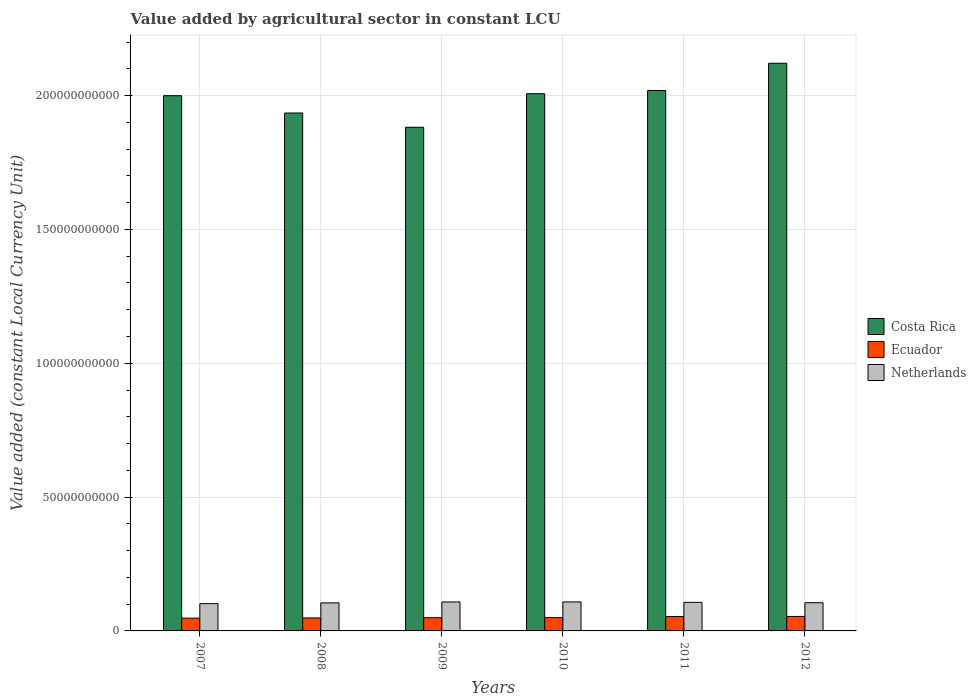How many groups of bars are there?
Ensure brevity in your answer.  6. How many bars are there on the 5th tick from the right?
Offer a terse response. 3. What is the label of the 5th group of bars from the left?
Provide a succinct answer. 2011. What is the value added by agricultural sector in Netherlands in 2007?
Offer a very short reply. 1.02e+1. Across all years, what is the maximum value added by agricultural sector in Ecuador?
Provide a succinct answer. 5.41e+09. Across all years, what is the minimum value added by agricultural sector in Ecuador?
Your answer should be compact. 4.77e+09. In which year was the value added by agricultural sector in Costa Rica maximum?
Ensure brevity in your answer.  2012. What is the total value added by agricultural sector in Costa Rica in the graph?
Your answer should be compact. 1.20e+12. What is the difference between the value added by agricultural sector in Ecuador in 2007 and that in 2010?
Provide a short and direct response. -1.99e+08. What is the difference between the value added by agricultural sector in Netherlands in 2007 and the value added by agricultural sector in Costa Rica in 2010?
Provide a short and direct response. -1.90e+11. What is the average value added by agricultural sector in Costa Rica per year?
Provide a succinct answer. 1.99e+11. In the year 2007, what is the difference between the value added by agricultural sector in Ecuador and value added by agricultural sector in Costa Rica?
Give a very brief answer. -1.95e+11. In how many years, is the value added by agricultural sector in Costa Rica greater than 70000000000 LCU?
Your answer should be compact. 6. What is the ratio of the value added by agricultural sector in Costa Rica in 2007 to that in 2010?
Your answer should be very brief. 1. Is the value added by agricultural sector in Netherlands in 2007 less than that in 2010?
Your response must be concise. Yes. Is the difference between the value added by agricultural sector in Ecuador in 2008 and 2009 greater than the difference between the value added by agricultural sector in Costa Rica in 2008 and 2009?
Provide a short and direct response. No. What is the difference between the highest and the second highest value added by agricultural sector in Netherlands?
Your response must be concise. 9.42e+06. What is the difference between the highest and the lowest value added by agricultural sector in Netherlands?
Offer a very short reply. 6.34e+08. What does the 2nd bar from the left in 2007 represents?
Give a very brief answer. Ecuador. Is it the case that in every year, the sum of the value added by agricultural sector in Ecuador and value added by agricultural sector in Netherlands is greater than the value added by agricultural sector in Costa Rica?
Offer a terse response. No. How many bars are there?
Provide a short and direct response. 18. Are the values on the major ticks of Y-axis written in scientific E-notation?
Your response must be concise. No. How many legend labels are there?
Your answer should be compact. 3. How are the legend labels stacked?
Offer a very short reply. Vertical. What is the title of the graph?
Provide a succinct answer. Value added by agricultural sector in constant LCU. What is the label or title of the Y-axis?
Your response must be concise. Value added (constant Local Currency Unit). What is the Value added (constant Local Currency Unit) in Costa Rica in 2007?
Offer a very short reply. 2.00e+11. What is the Value added (constant Local Currency Unit) in Ecuador in 2007?
Make the answer very short. 4.77e+09. What is the Value added (constant Local Currency Unit) in Netherlands in 2007?
Your answer should be very brief. 1.02e+1. What is the Value added (constant Local Currency Unit) of Costa Rica in 2008?
Your answer should be very brief. 1.93e+11. What is the Value added (constant Local Currency Unit) in Ecuador in 2008?
Provide a short and direct response. 4.85e+09. What is the Value added (constant Local Currency Unit) of Netherlands in 2008?
Provide a succinct answer. 1.05e+1. What is the Value added (constant Local Currency Unit) of Costa Rica in 2009?
Give a very brief answer. 1.88e+11. What is the Value added (constant Local Currency Unit) in Ecuador in 2009?
Your answer should be compact. 4.93e+09. What is the Value added (constant Local Currency Unit) of Netherlands in 2009?
Ensure brevity in your answer.  1.08e+1. What is the Value added (constant Local Currency Unit) in Costa Rica in 2010?
Give a very brief answer. 2.01e+11. What is the Value added (constant Local Currency Unit) in Ecuador in 2010?
Provide a succinct answer. 4.97e+09. What is the Value added (constant Local Currency Unit) of Netherlands in 2010?
Your response must be concise. 1.08e+1. What is the Value added (constant Local Currency Unit) of Costa Rica in 2011?
Your answer should be compact. 2.02e+11. What is the Value added (constant Local Currency Unit) in Ecuador in 2011?
Give a very brief answer. 5.37e+09. What is the Value added (constant Local Currency Unit) in Netherlands in 2011?
Provide a short and direct response. 1.07e+1. What is the Value added (constant Local Currency Unit) in Costa Rica in 2012?
Offer a terse response. 2.12e+11. What is the Value added (constant Local Currency Unit) in Ecuador in 2012?
Your response must be concise. 5.41e+09. What is the Value added (constant Local Currency Unit) of Netherlands in 2012?
Offer a terse response. 1.05e+1. Across all years, what is the maximum Value added (constant Local Currency Unit) in Costa Rica?
Ensure brevity in your answer.  2.12e+11. Across all years, what is the maximum Value added (constant Local Currency Unit) of Ecuador?
Offer a very short reply. 5.41e+09. Across all years, what is the maximum Value added (constant Local Currency Unit) in Netherlands?
Your answer should be very brief. 1.08e+1. Across all years, what is the minimum Value added (constant Local Currency Unit) in Costa Rica?
Your answer should be very brief. 1.88e+11. Across all years, what is the minimum Value added (constant Local Currency Unit) of Ecuador?
Ensure brevity in your answer.  4.77e+09. Across all years, what is the minimum Value added (constant Local Currency Unit) of Netherlands?
Your response must be concise. 1.02e+1. What is the total Value added (constant Local Currency Unit) in Costa Rica in the graph?
Your response must be concise. 1.20e+12. What is the total Value added (constant Local Currency Unit) of Ecuador in the graph?
Offer a very short reply. 3.03e+1. What is the total Value added (constant Local Currency Unit) in Netherlands in the graph?
Your answer should be compact. 6.35e+1. What is the difference between the Value added (constant Local Currency Unit) of Costa Rica in 2007 and that in 2008?
Your answer should be compact. 6.47e+09. What is the difference between the Value added (constant Local Currency Unit) of Ecuador in 2007 and that in 2008?
Offer a very short reply. -7.96e+07. What is the difference between the Value added (constant Local Currency Unit) in Netherlands in 2007 and that in 2008?
Give a very brief answer. -2.80e+08. What is the difference between the Value added (constant Local Currency Unit) in Costa Rica in 2007 and that in 2009?
Your response must be concise. 1.18e+1. What is the difference between the Value added (constant Local Currency Unit) of Ecuador in 2007 and that in 2009?
Keep it short and to the point. -1.63e+08. What is the difference between the Value added (constant Local Currency Unit) of Netherlands in 2007 and that in 2009?
Provide a succinct answer. -6.25e+08. What is the difference between the Value added (constant Local Currency Unit) of Costa Rica in 2007 and that in 2010?
Keep it short and to the point. -7.38e+08. What is the difference between the Value added (constant Local Currency Unit) of Ecuador in 2007 and that in 2010?
Offer a very short reply. -1.99e+08. What is the difference between the Value added (constant Local Currency Unit) of Netherlands in 2007 and that in 2010?
Your answer should be compact. -6.34e+08. What is the difference between the Value added (constant Local Currency Unit) in Costa Rica in 2007 and that in 2011?
Offer a very short reply. -1.95e+09. What is the difference between the Value added (constant Local Currency Unit) of Ecuador in 2007 and that in 2011?
Your response must be concise. -5.94e+08. What is the difference between the Value added (constant Local Currency Unit) in Netherlands in 2007 and that in 2011?
Offer a terse response. -4.80e+08. What is the difference between the Value added (constant Local Currency Unit) of Costa Rica in 2007 and that in 2012?
Your answer should be very brief. -1.21e+1. What is the difference between the Value added (constant Local Currency Unit) in Ecuador in 2007 and that in 2012?
Your response must be concise. -6.36e+08. What is the difference between the Value added (constant Local Currency Unit) in Netherlands in 2007 and that in 2012?
Give a very brief answer. -3.47e+08. What is the difference between the Value added (constant Local Currency Unit) in Costa Rica in 2008 and that in 2009?
Ensure brevity in your answer.  5.33e+09. What is the difference between the Value added (constant Local Currency Unit) of Ecuador in 2008 and that in 2009?
Ensure brevity in your answer.  -8.32e+07. What is the difference between the Value added (constant Local Currency Unit) of Netherlands in 2008 and that in 2009?
Ensure brevity in your answer.  -3.44e+08. What is the difference between the Value added (constant Local Currency Unit) of Costa Rica in 2008 and that in 2010?
Keep it short and to the point. -7.21e+09. What is the difference between the Value added (constant Local Currency Unit) in Ecuador in 2008 and that in 2010?
Offer a very short reply. -1.20e+08. What is the difference between the Value added (constant Local Currency Unit) of Netherlands in 2008 and that in 2010?
Provide a short and direct response. -3.54e+08. What is the difference between the Value added (constant Local Currency Unit) in Costa Rica in 2008 and that in 2011?
Make the answer very short. -8.43e+09. What is the difference between the Value added (constant Local Currency Unit) in Ecuador in 2008 and that in 2011?
Offer a very short reply. -5.14e+08. What is the difference between the Value added (constant Local Currency Unit) in Netherlands in 2008 and that in 2011?
Your answer should be very brief. -2.00e+08. What is the difference between the Value added (constant Local Currency Unit) in Costa Rica in 2008 and that in 2012?
Give a very brief answer. -1.86e+1. What is the difference between the Value added (constant Local Currency Unit) in Ecuador in 2008 and that in 2012?
Make the answer very short. -5.56e+08. What is the difference between the Value added (constant Local Currency Unit) of Netherlands in 2008 and that in 2012?
Offer a very short reply. -6.66e+07. What is the difference between the Value added (constant Local Currency Unit) in Costa Rica in 2009 and that in 2010?
Your answer should be very brief. -1.25e+1. What is the difference between the Value added (constant Local Currency Unit) in Ecuador in 2009 and that in 2010?
Provide a succinct answer. -3.65e+07. What is the difference between the Value added (constant Local Currency Unit) in Netherlands in 2009 and that in 2010?
Make the answer very short. -9.42e+06. What is the difference between the Value added (constant Local Currency Unit) of Costa Rica in 2009 and that in 2011?
Your answer should be compact. -1.38e+1. What is the difference between the Value added (constant Local Currency Unit) of Ecuador in 2009 and that in 2011?
Your response must be concise. -4.31e+08. What is the difference between the Value added (constant Local Currency Unit) of Netherlands in 2009 and that in 2011?
Give a very brief answer. 1.45e+08. What is the difference between the Value added (constant Local Currency Unit) of Costa Rica in 2009 and that in 2012?
Provide a succinct answer. -2.39e+1. What is the difference between the Value added (constant Local Currency Unit) of Ecuador in 2009 and that in 2012?
Keep it short and to the point. -4.73e+08. What is the difference between the Value added (constant Local Currency Unit) in Netherlands in 2009 and that in 2012?
Keep it short and to the point. 2.78e+08. What is the difference between the Value added (constant Local Currency Unit) in Costa Rica in 2010 and that in 2011?
Give a very brief answer. -1.22e+09. What is the difference between the Value added (constant Local Currency Unit) of Ecuador in 2010 and that in 2011?
Give a very brief answer. -3.95e+08. What is the difference between the Value added (constant Local Currency Unit) of Netherlands in 2010 and that in 2011?
Make the answer very short. 1.54e+08. What is the difference between the Value added (constant Local Currency Unit) of Costa Rica in 2010 and that in 2012?
Provide a succinct answer. -1.14e+1. What is the difference between the Value added (constant Local Currency Unit) of Ecuador in 2010 and that in 2012?
Provide a succinct answer. -4.36e+08. What is the difference between the Value added (constant Local Currency Unit) in Netherlands in 2010 and that in 2012?
Offer a very short reply. 2.87e+08. What is the difference between the Value added (constant Local Currency Unit) of Costa Rica in 2011 and that in 2012?
Offer a very short reply. -1.02e+1. What is the difference between the Value added (constant Local Currency Unit) in Ecuador in 2011 and that in 2012?
Ensure brevity in your answer.  -4.16e+07. What is the difference between the Value added (constant Local Currency Unit) of Netherlands in 2011 and that in 2012?
Offer a terse response. 1.33e+08. What is the difference between the Value added (constant Local Currency Unit) in Costa Rica in 2007 and the Value added (constant Local Currency Unit) in Ecuador in 2008?
Your response must be concise. 1.95e+11. What is the difference between the Value added (constant Local Currency Unit) in Costa Rica in 2007 and the Value added (constant Local Currency Unit) in Netherlands in 2008?
Keep it short and to the point. 1.89e+11. What is the difference between the Value added (constant Local Currency Unit) in Ecuador in 2007 and the Value added (constant Local Currency Unit) in Netherlands in 2008?
Provide a short and direct response. -5.70e+09. What is the difference between the Value added (constant Local Currency Unit) of Costa Rica in 2007 and the Value added (constant Local Currency Unit) of Ecuador in 2009?
Make the answer very short. 1.95e+11. What is the difference between the Value added (constant Local Currency Unit) of Costa Rica in 2007 and the Value added (constant Local Currency Unit) of Netherlands in 2009?
Give a very brief answer. 1.89e+11. What is the difference between the Value added (constant Local Currency Unit) of Ecuador in 2007 and the Value added (constant Local Currency Unit) of Netherlands in 2009?
Offer a terse response. -6.05e+09. What is the difference between the Value added (constant Local Currency Unit) in Costa Rica in 2007 and the Value added (constant Local Currency Unit) in Ecuador in 2010?
Provide a short and direct response. 1.95e+11. What is the difference between the Value added (constant Local Currency Unit) in Costa Rica in 2007 and the Value added (constant Local Currency Unit) in Netherlands in 2010?
Ensure brevity in your answer.  1.89e+11. What is the difference between the Value added (constant Local Currency Unit) in Ecuador in 2007 and the Value added (constant Local Currency Unit) in Netherlands in 2010?
Provide a short and direct response. -6.06e+09. What is the difference between the Value added (constant Local Currency Unit) of Costa Rica in 2007 and the Value added (constant Local Currency Unit) of Ecuador in 2011?
Your answer should be compact. 1.95e+11. What is the difference between the Value added (constant Local Currency Unit) of Costa Rica in 2007 and the Value added (constant Local Currency Unit) of Netherlands in 2011?
Your response must be concise. 1.89e+11. What is the difference between the Value added (constant Local Currency Unit) in Ecuador in 2007 and the Value added (constant Local Currency Unit) in Netherlands in 2011?
Keep it short and to the point. -5.90e+09. What is the difference between the Value added (constant Local Currency Unit) of Costa Rica in 2007 and the Value added (constant Local Currency Unit) of Ecuador in 2012?
Your answer should be compact. 1.95e+11. What is the difference between the Value added (constant Local Currency Unit) of Costa Rica in 2007 and the Value added (constant Local Currency Unit) of Netherlands in 2012?
Provide a succinct answer. 1.89e+11. What is the difference between the Value added (constant Local Currency Unit) in Ecuador in 2007 and the Value added (constant Local Currency Unit) in Netherlands in 2012?
Ensure brevity in your answer.  -5.77e+09. What is the difference between the Value added (constant Local Currency Unit) in Costa Rica in 2008 and the Value added (constant Local Currency Unit) in Ecuador in 2009?
Offer a very short reply. 1.89e+11. What is the difference between the Value added (constant Local Currency Unit) of Costa Rica in 2008 and the Value added (constant Local Currency Unit) of Netherlands in 2009?
Provide a succinct answer. 1.83e+11. What is the difference between the Value added (constant Local Currency Unit) of Ecuador in 2008 and the Value added (constant Local Currency Unit) of Netherlands in 2009?
Provide a short and direct response. -5.97e+09. What is the difference between the Value added (constant Local Currency Unit) of Costa Rica in 2008 and the Value added (constant Local Currency Unit) of Ecuador in 2010?
Give a very brief answer. 1.89e+11. What is the difference between the Value added (constant Local Currency Unit) in Costa Rica in 2008 and the Value added (constant Local Currency Unit) in Netherlands in 2010?
Give a very brief answer. 1.83e+11. What is the difference between the Value added (constant Local Currency Unit) in Ecuador in 2008 and the Value added (constant Local Currency Unit) in Netherlands in 2010?
Provide a short and direct response. -5.98e+09. What is the difference between the Value added (constant Local Currency Unit) of Costa Rica in 2008 and the Value added (constant Local Currency Unit) of Ecuador in 2011?
Offer a terse response. 1.88e+11. What is the difference between the Value added (constant Local Currency Unit) of Costa Rica in 2008 and the Value added (constant Local Currency Unit) of Netherlands in 2011?
Offer a very short reply. 1.83e+11. What is the difference between the Value added (constant Local Currency Unit) in Ecuador in 2008 and the Value added (constant Local Currency Unit) in Netherlands in 2011?
Provide a succinct answer. -5.82e+09. What is the difference between the Value added (constant Local Currency Unit) in Costa Rica in 2008 and the Value added (constant Local Currency Unit) in Ecuador in 2012?
Provide a short and direct response. 1.88e+11. What is the difference between the Value added (constant Local Currency Unit) in Costa Rica in 2008 and the Value added (constant Local Currency Unit) in Netherlands in 2012?
Offer a very short reply. 1.83e+11. What is the difference between the Value added (constant Local Currency Unit) in Ecuador in 2008 and the Value added (constant Local Currency Unit) in Netherlands in 2012?
Your answer should be compact. -5.69e+09. What is the difference between the Value added (constant Local Currency Unit) in Costa Rica in 2009 and the Value added (constant Local Currency Unit) in Ecuador in 2010?
Give a very brief answer. 1.83e+11. What is the difference between the Value added (constant Local Currency Unit) of Costa Rica in 2009 and the Value added (constant Local Currency Unit) of Netherlands in 2010?
Offer a terse response. 1.77e+11. What is the difference between the Value added (constant Local Currency Unit) in Ecuador in 2009 and the Value added (constant Local Currency Unit) in Netherlands in 2010?
Offer a terse response. -5.89e+09. What is the difference between the Value added (constant Local Currency Unit) of Costa Rica in 2009 and the Value added (constant Local Currency Unit) of Ecuador in 2011?
Offer a terse response. 1.83e+11. What is the difference between the Value added (constant Local Currency Unit) of Costa Rica in 2009 and the Value added (constant Local Currency Unit) of Netherlands in 2011?
Make the answer very short. 1.77e+11. What is the difference between the Value added (constant Local Currency Unit) in Ecuador in 2009 and the Value added (constant Local Currency Unit) in Netherlands in 2011?
Make the answer very short. -5.74e+09. What is the difference between the Value added (constant Local Currency Unit) of Costa Rica in 2009 and the Value added (constant Local Currency Unit) of Ecuador in 2012?
Offer a very short reply. 1.83e+11. What is the difference between the Value added (constant Local Currency Unit) of Costa Rica in 2009 and the Value added (constant Local Currency Unit) of Netherlands in 2012?
Your answer should be very brief. 1.78e+11. What is the difference between the Value added (constant Local Currency Unit) of Ecuador in 2009 and the Value added (constant Local Currency Unit) of Netherlands in 2012?
Ensure brevity in your answer.  -5.61e+09. What is the difference between the Value added (constant Local Currency Unit) of Costa Rica in 2010 and the Value added (constant Local Currency Unit) of Ecuador in 2011?
Make the answer very short. 1.95e+11. What is the difference between the Value added (constant Local Currency Unit) of Costa Rica in 2010 and the Value added (constant Local Currency Unit) of Netherlands in 2011?
Provide a succinct answer. 1.90e+11. What is the difference between the Value added (constant Local Currency Unit) of Ecuador in 2010 and the Value added (constant Local Currency Unit) of Netherlands in 2011?
Your answer should be very brief. -5.70e+09. What is the difference between the Value added (constant Local Currency Unit) in Costa Rica in 2010 and the Value added (constant Local Currency Unit) in Ecuador in 2012?
Keep it short and to the point. 1.95e+11. What is the difference between the Value added (constant Local Currency Unit) of Costa Rica in 2010 and the Value added (constant Local Currency Unit) of Netherlands in 2012?
Your answer should be very brief. 1.90e+11. What is the difference between the Value added (constant Local Currency Unit) of Ecuador in 2010 and the Value added (constant Local Currency Unit) of Netherlands in 2012?
Your response must be concise. -5.57e+09. What is the difference between the Value added (constant Local Currency Unit) in Costa Rica in 2011 and the Value added (constant Local Currency Unit) in Ecuador in 2012?
Provide a short and direct response. 1.96e+11. What is the difference between the Value added (constant Local Currency Unit) of Costa Rica in 2011 and the Value added (constant Local Currency Unit) of Netherlands in 2012?
Ensure brevity in your answer.  1.91e+11. What is the difference between the Value added (constant Local Currency Unit) of Ecuador in 2011 and the Value added (constant Local Currency Unit) of Netherlands in 2012?
Give a very brief answer. -5.17e+09. What is the average Value added (constant Local Currency Unit) of Costa Rica per year?
Offer a very short reply. 1.99e+11. What is the average Value added (constant Local Currency Unit) of Ecuador per year?
Your answer should be very brief. 5.05e+09. What is the average Value added (constant Local Currency Unit) of Netherlands per year?
Give a very brief answer. 1.06e+1. In the year 2007, what is the difference between the Value added (constant Local Currency Unit) in Costa Rica and Value added (constant Local Currency Unit) in Ecuador?
Your answer should be compact. 1.95e+11. In the year 2007, what is the difference between the Value added (constant Local Currency Unit) in Costa Rica and Value added (constant Local Currency Unit) in Netherlands?
Your response must be concise. 1.90e+11. In the year 2007, what is the difference between the Value added (constant Local Currency Unit) of Ecuador and Value added (constant Local Currency Unit) of Netherlands?
Provide a short and direct response. -5.42e+09. In the year 2008, what is the difference between the Value added (constant Local Currency Unit) in Costa Rica and Value added (constant Local Currency Unit) in Ecuador?
Provide a succinct answer. 1.89e+11. In the year 2008, what is the difference between the Value added (constant Local Currency Unit) in Costa Rica and Value added (constant Local Currency Unit) in Netherlands?
Your answer should be compact. 1.83e+11. In the year 2008, what is the difference between the Value added (constant Local Currency Unit) in Ecuador and Value added (constant Local Currency Unit) in Netherlands?
Keep it short and to the point. -5.62e+09. In the year 2009, what is the difference between the Value added (constant Local Currency Unit) of Costa Rica and Value added (constant Local Currency Unit) of Ecuador?
Ensure brevity in your answer.  1.83e+11. In the year 2009, what is the difference between the Value added (constant Local Currency Unit) of Costa Rica and Value added (constant Local Currency Unit) of Netherlands?
Give a very brief answer. 1.77e+11. In the year 2009, what is the difference between the Value added (constant Local Currency Unit) in Ecuador and Value added (constant Local Currency Unit) in Netherlands?
Offer a terse response. -5.88e+09. In the year 2010, what is the difference between the Value added (constant Local Currency Unit) of Costa Rica and Value added (constant Local Currency Unit) of Ecuador?
Offer a terse response. 1.96e+11. In the year 2010, what is the difference between the Value added (constant Local Currency Unit) of Costa Rica and Value added (constant Local Currency Unit) of Netherlands?
Provide a short and direct response. 1.90e+11. In the year 2010, what is the difference between the Value added (constant Local Currency Unit) of Ecuador and Value added (constant Local Currency Unit) of Netherlands?
Provide a short and direct response. -5.86e+09. In the year 2011, what is the difference between the Value added (constant Local Currency Unit) in Costa Rica and Value added (constant Local Currency Unit) in Ecuador?
Ensure brevity in your answer.  1.97e+11. In the year 2011, what is the difference between the Value added (constant Local Currency Unit) of Costa Rica and Value added (constant Local Currency Unit) of Netherlands?
Make the answer very short. 1.91e+11. In the year 2011, what is the difference between the Value added (constant Local Currency Unit) in Ecuador and Value added (constant Local Currency Unit) in Netherlands?
Your answer should be very brief. -5.31e+09. In the year 2012, what is the difference between the Value added (constant Local Currency Unit) of Costa Rica and Value added (constant Local Currency Unit) of Ecuador?
Offer a very short reply. 2.07e+11. In the year 2012, what is the difference between the Value added (constant Local Currency Unit) of Costa Rica and Value added (constant Local Currency Unit) of Netherlands?
Offer a very short reply. 2.02e+11. In the year 2012, what is the difference between the Value added (constant Local Currency Unit) in Ecuador and Value added (constant Local Currency Unit) in Netherlands?
Offer a terse response. -5.13e+09. What is the ratio of the Value added (constant Local Currency Unit) in Costa Rica in 2007 to that in 2008?
Provide a short and direct response. 1.03. What is the ratio of the Value added (constant Local Currency Unit) of Ecuador in 2007 to that in 2008?
Your answer should be very brief. 0.98. What is the ratio of the Value added (constant Local Currency Unit) of Netherlands in 2007 to that in 2008?
Keep it short and to the point. 0.97. What is the ratio of the Value added (constant Local Currency Unit) of Costa Rica in 2007 to that in 2009?
Your answer should be compact. 1.06. What is the ratio of the Value added (constant Local Currency Unit) of Ecuador in 2007 to that in 2009?
Make the answer very short. 0.97. What is the ratio of the Value added (constant Local Currency Unit) of Netherlands in 2007 to that in 2009?
Keep it short and to the point. 0.94. What is the ratio of the Value added (constant Local Currency Unit) in Ecuador in 2007 to that in 2010?
Provide a short and direct response. 0.96. What is the ratio of the Value added (constant Local Currency Unit) in Netherlands in 2007 to that in 2010?
Your response must be concise. 0.94. What is the ratio of the Value added (constant Local Currency Unit) in Costa Rica in 2007 to that in 2011?
Make the answer very short. 0.99. What is the ratio of the Value added (constant Local Currency Unit) in Ecuador in 2007 to that in 2011?
Give a very brief answer. 0.89. What is the ratio of the Value added (constant Local Currency Unit) in Netherlands in 2007 to that in 2011?
Your answer should be very brief. 0.95. What is the ratio of the Value added (constant Local Currency Unit) in Costa Rica in 2007 to that in 2012?
Offer a very short reply. 0.94. What is the ratio of the Value added (constant Local Currency Unit) in Ecuador in 2007 to that in 2012?
Your answer should be compact. 0.88. What is the ratio of the Value added (constant Local Currency Unit) of Netherlands in 2007 to that in 2012?
Provide a short and direct response. 0.97. What is the ratio of the Value added (constant Local Currency Unit) of Costa Rica in 2008 to that in 2009?
Ensure brevity in your answer.  1.03. What is the ratio of the Value added (constant Local Currency Unit) of Ecuador in 2008 to that in 2009?
Your answer should be compact. 0.98. What is the ratio of the Value added (constant Local Currency Unit) of Netherlands in 2008 to that in 2009?
Offer a terse response. 0.97. What is the ratio of the Value added (constant Local Currency Unit) of Costa Rica in 2008 to that in 2010?
Your answer should be very brief. 0.96. What is the ratio of the Value added (constant Local Currency Unit) of Ecuador in 2008 to that in 2010?
Ensure brevity in your answer.  0.98. What is the ratio of the Value added (constant Local Currency Unit) in Netherlands in 2008 to that in 2010?
Ensure brevity in your answer.  0.97. What is the ratio of the Value added (constant Local Currency Unit) of Ecuador in 2008 to that in 2011?
Provide a short and direct response. 0.9. What is the ratio of the Value added (constant Local Currency Unit) of Netherlands in 2008 to that in 2011?
Ensure brevity in your answer.  0.98. What is the ratio of the Value added (constant Local Currency Unit) of Costa Rica in 2008 to that in 2012?
Your answer should be very brief. 0.91. What is the ratio of the Value added (constant Local Currency Unit) in Ecuador in 2008 to that in 2012?
Provide a succinct answer. 0.9. What is the ratio of the Value added (constant Local Currency Unit) of Netherlands in 2008 to that in 2012?
Ensure brevity in your answer.  0.99. What is the ratio of the Value added (constant Local Currency Unit) in Costa Rica in 2009 to that in 2010?
Ensure brevity in your answer.  0.94. What is the ratio of the Value added (constant Local Currency Unit) in Netherlands in 2009 to that in 2010?
Provide a succinct answer. 1. What is the ratio of the Value added (constant Local Currency Unit) in Costa Rica in 2009 to that in 2011?
Provide a succinct answer. 0.93. What is the ratio of the Value added (constant Local Currency Unit) of Ecuador in 2009 to that in 2011?
Provide a succinct answer. 0.92. What is the ratio of the Value added (constant Local Currency Unit) in Netherlands in 2009 to that in 2011?
Offer a terse response. 1.01. What is the ratio of the Value added (constant Local Currency Unit) of Costa Rica in 2009 to that in 2012?
Ensure brevity in your answer.  0.89. What is the ratio of the Value added (constant Local Currency Unit) in Ecuador in 2009 to that in 2012?
Offer a terse response. 0.91. What is the ratio of the Value added (constant Local Currency Unit) in Netherlands in 2009 to that in 2012?
Your answer should be very brief. 1.03. What is the ratio of the Value added (constant Local Currency Unit) of Ecuador in 2010 to that in 2011?
Keep it short and to the point. 0.93. What is the ratio of the Value added (constant Local Currency Unit) in Netherlands in 2010 to that in 2011?
Keep it short and to the point. 1.01. What is the ratio of the Value added (constant Local Currency Unit) in Costa Rica in 2010 to that in 2012?
Offer a very short reply. 0.95. What is the ratio of the Value added (constant Local Currency Unit) of Ecuador in 2010 to that in 2012?
Ensure brevity in your answer.  0.92. What is the ratio of the Value added (constant Local Currency Unit) of Netherlands in 2010 to that in 2012?
Ensure brevity in your answer.  1.03. What is the ratio of the Value added (constant Local Currency Unit) of Costa Rica in 2011 to that in 2012?
Provide a succinct answer. 0.95. What is the ratio of the Value added (constant Local Currency Unit) of Netherlands in 2011 to that in 2012?
Provide a succinct answer. 1.01. What is the difference between the highest and the second highest Value added (constant Local Currency Unit) in Costa Rica?
Keep it short and to the point. 1.02e+1. What is the difference between the highest and the second highest Value added (constant Local Currency Unit) of Ecuador?
Offer a terse response. 4.16e+07. What is the difference between the highest and the second highest Value added (constant Local Currency Unit) in Netherlands?
Ensure brevity in your answer.  9.42e+06. What is the difference between the highest and the lowest Value added (constant Local Currency Unit) of Costa Rica?
Offer a terse response. 2.39e+1. What is the difference between the highest and the lowest Value added (constant Local Currency Unit) of Ecuador?
Give a very brief answer. 6.36e+08. What is the difference between the highest and the lowest Value added (constant Local Currency Unit) of Netherlands?
Keep it short and to the point. 6.34e+08. 